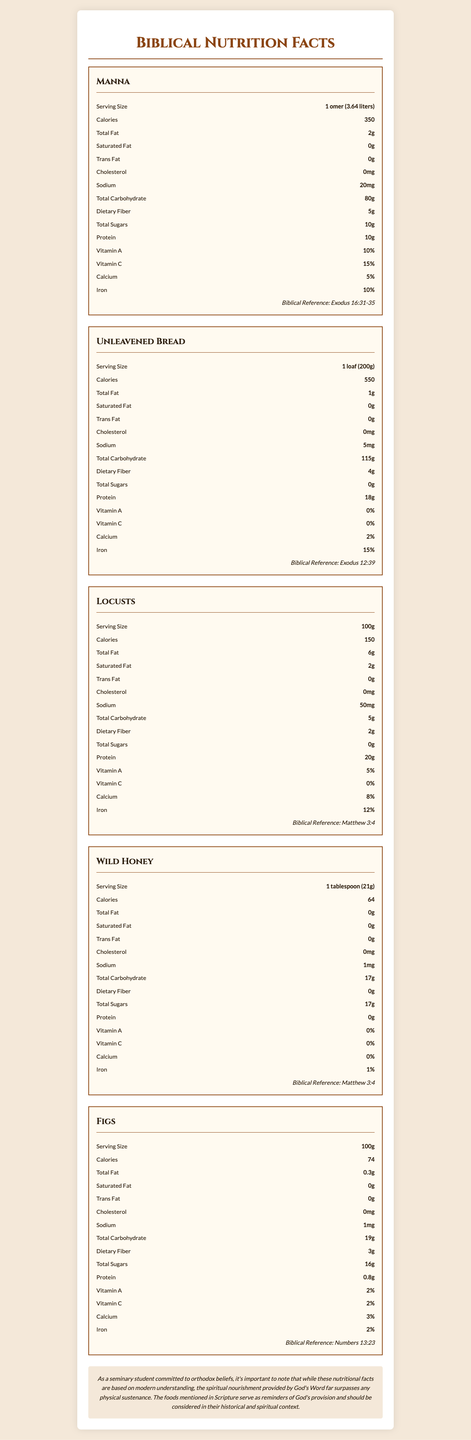What is the serving size of Unleavened Bread? According to the document, the serving size for Unleavened Bread is listed as 1 loaf (200g).
Answer: 1 loaf (200g) How many calories are in one serving of Figs? The document states that one serving size (100g) of Figs contains 74 calories.
Answer: 74 What is the protein content in Locusts per 100g serving? The nutrition label for Locusts specifies that there is 20g of protein per 100g serving.
Answer: 20g What is the biblical reference for Manna? The document lists Exodus 16:31-35 as the biblical reference for Manna.
Answer: Exodus 16:31-35 Which food has the highest sodium content per serving? Based on the nutrition facts, Locusts have the highest sodium content at 50mg per 100g serving.
Answer: Locusts Which food contains the most dietary fiber per serving? A. Manna B. Unleavened Bread C. Locusts D. Figs Manna has the highest dietary fiber content at 5g per serving.
Answer: A How much iron does Unleavened Bread provide per serving in percentage? The document shows that Unleavened Bread provides 15% of the daily recommended iron per serving.
Answer: 15% Does Wild Honey contain any protein per serving? According to the document, Wild Honey has a protein content of 0g per tablespoon serving.
Answer: No Summarize the document in a few sentences. The document provides a modern nutritional breakdown of biblical foods, emphasizing the importance of both physical and spiritual sustenance.
Answer: The document displays nutritional information for common foods mentioned in biblical passages, including Manna, Unleavened Bread, Locusts, Wild Honey, and Figs. Each food item is detailed with serving size, calories, macronutrients, vitamins, and biblical references. A disclaimer notes that while these facts are based on modern understanding, spiritual nourishment from God's Word is paramount. What type of flour was used to make the Unleavened Bread? The document does not provide information on the type of flour used for making Unleavened Bread.
Answer: Cannot be determined 